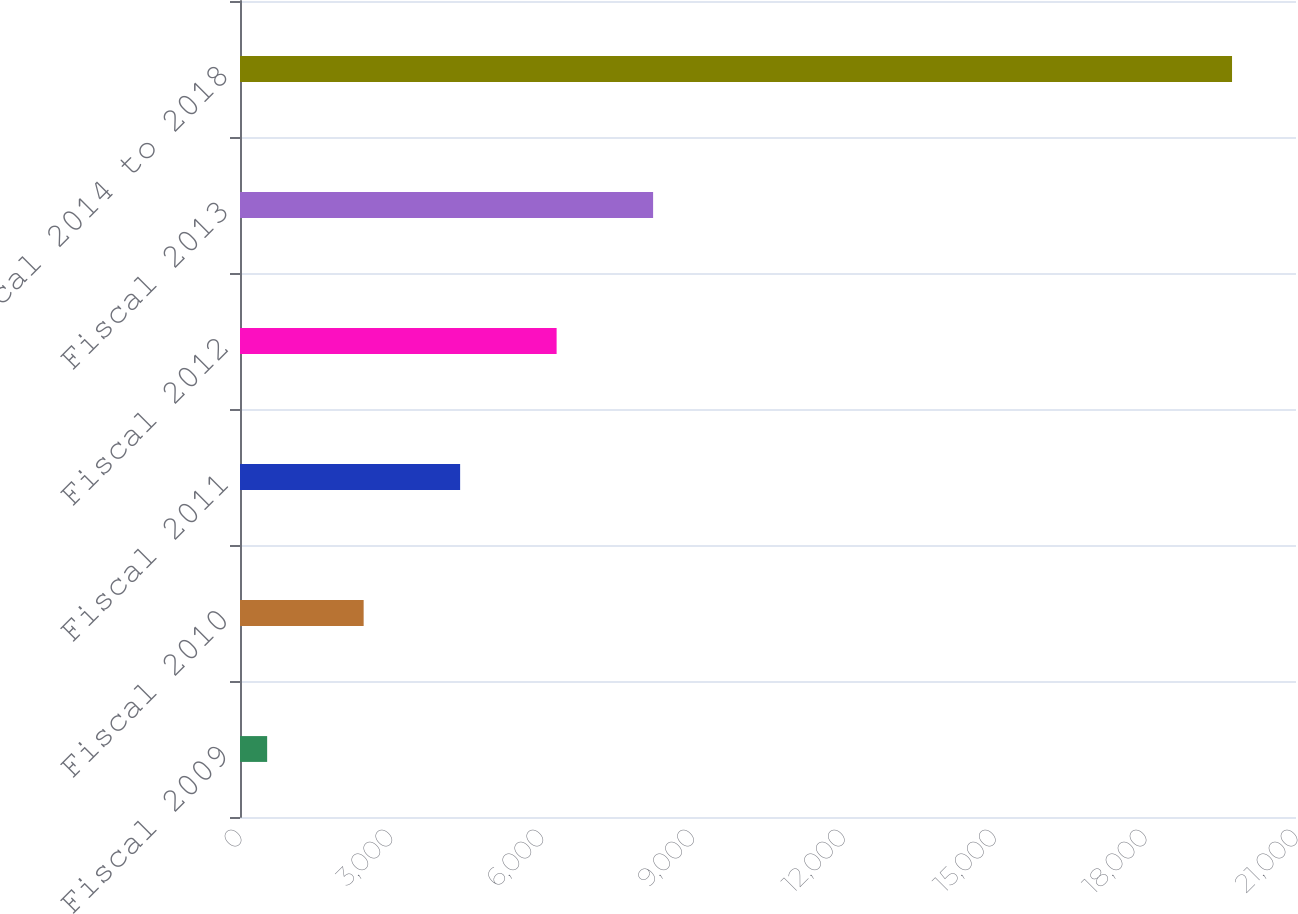Convert chart to OTSL. <chart><loc_0><loc_0><loc_500><loc_500><bar_chart><fcel>Fiscal 2009<fcel>Fiscal 2010<fcel>Fiscal 2011<fcel>Fiscal 2012<fcel>Fiscal 2013<fcel>Fiscal 2014 to 2018<nl><fcel>540<fcel>2458.8<fcel>4377.6<fcel>6296.4<fcel>8215.2<fcel>19728<nl></chart> 